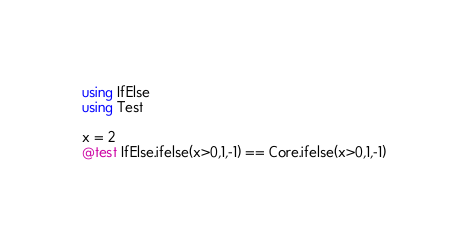Convert code to text. <code><loc_0><loc_0><loc_500><loc_500><_Julia_>using IfElse
using Test

x = 2
@test IfElse.ifelse(x>0,1,-1) == Core.ifelse(x>0,1,-1)
</code> 